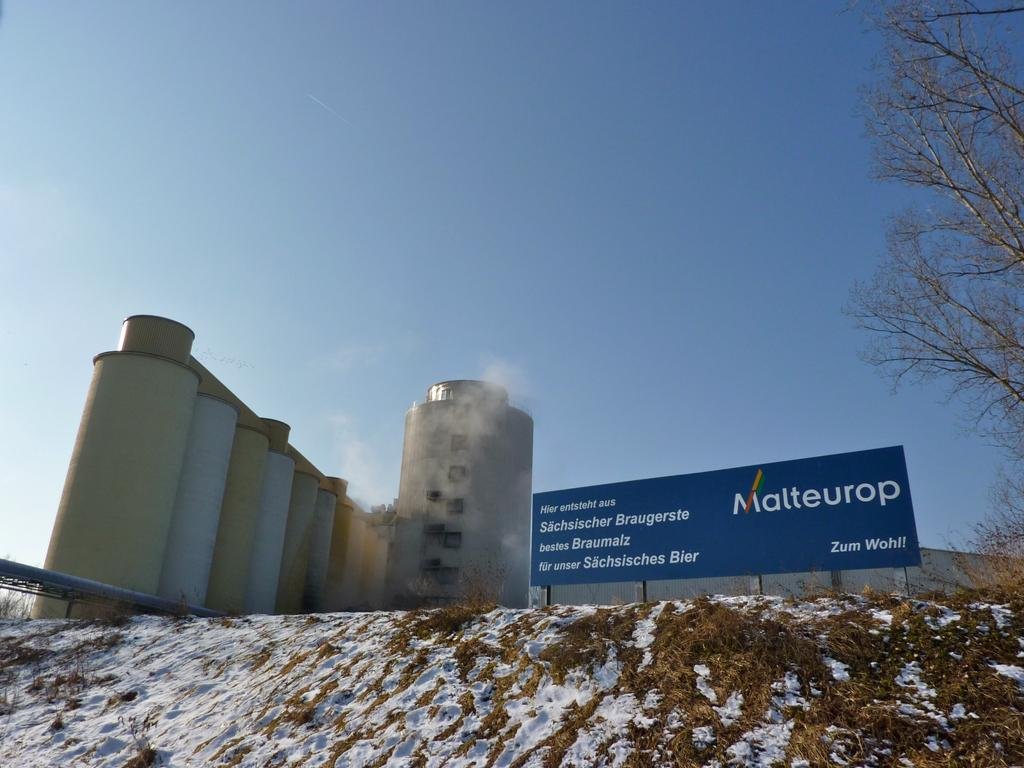<image>
Write a terse but informative summary of the picture. a buliding with a sign out front with Malteurop on it 